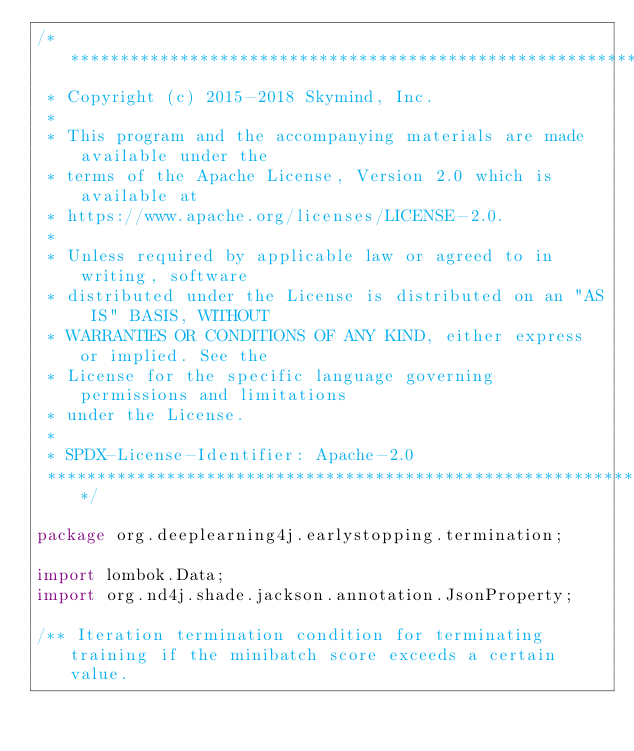<code> <loc_0><loc_0><loc_500><loc_500><_Java_>/*******************************************************************************
 * Copyright (c) 2015-2018 Skymind, Inc.
 *
 * This program and the accompanying materials are made available under the
 * terms of the Apache License, Version 2.0 which is available at
 * https://www.apache.org/licenses/LICENSE-2.0.
 *
 * Unless required by applicable law or agreed to in writing, software
 * distributed under the License is distributed on an "AS IS" BASIS, WITHOUT
 * WARRANTIES OR CONDITIONS OF ANY KIND, either express or implied. See the
 * License for the specific language governing permissions and limitations
 * under the License.
 *
 * SPDX-License-Identifier: Apache-2.0
 ******************************************************************************/

package org.deeplearning4j.earlystopping.termination;

import lombok.Data;
import org.nd4j.shade.jackson.annotation.JsonProperty;

/** Iteration termination condition for terminating training if the minibatch score exceeds a certain value.</code> 